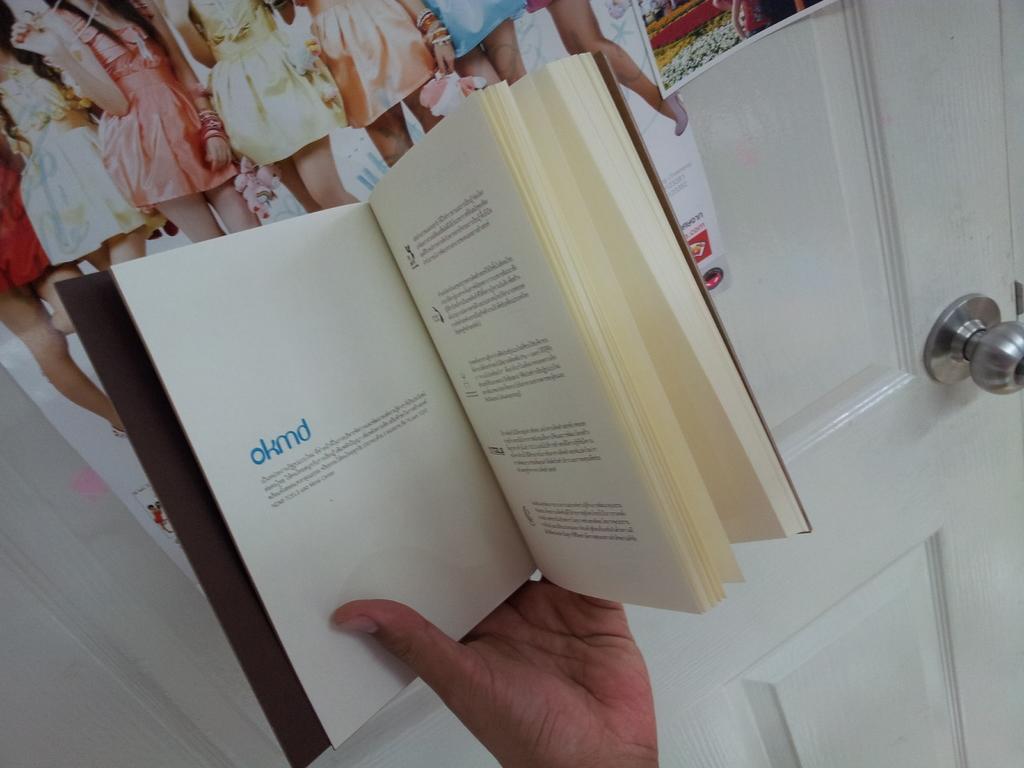What is in blue on this book?
Give a very brief answer. Okmd. 